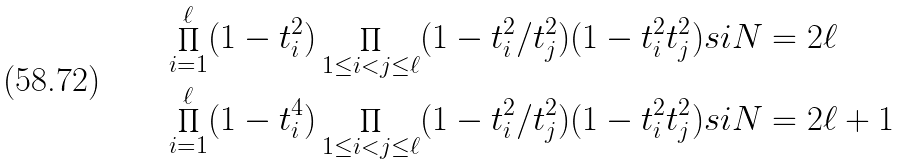<formula> <loc_0><loc_0><loc_500><loc_500>& \prod _ { i = 1 } ^ { \ell } ( 1 - t _ { i } ^ { 2 } ) \prod _ { 1 \leq i < j \leq \ell } ( 1 - t _ { i } ^ { 2 } / t _ { j } ^ { 2 } ) ( 1 - t _ { i } ^ { 2 } t _ { j } ^ { 2 } ) s i N = 2 \ell \\ & \prod _ { i = 1 } ^ { \ell } ( 1 - t _ { i } ^ { 4 } ) \prod _ { 1 \leq i < j \leq \ell } ( 1 - t _ { i } ^ { 2 } / t _ { j } ^ { 2 } ) ( 1 - t _ { i } ^ { 2 } t _ { j } ^ { 2 } ) s i N = 2 \ell + 1</formula> 